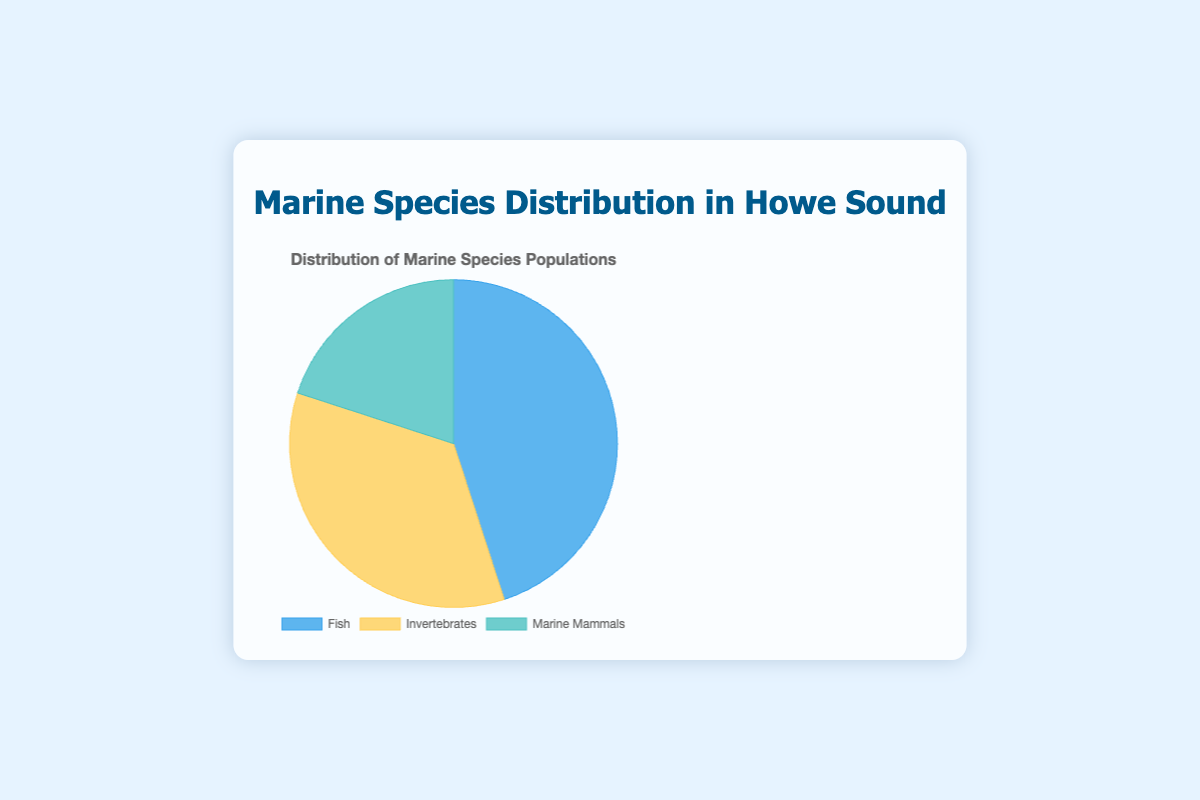How many types of marine species are represented in the diagram? There are labels for Fish, Invertebrates, and Marine Mammals. Counting these categories gives us 3 types.
Answer: 3 Which type of marine species has the highest population percentage in Howe Sound? The Fish category has the largest slice in the pie chart, labeled with 45%.
Answer: Fish What is the combined percentage of Fish and Invertebrates in the chart? Summing the percentages for Fish (45%) and Invertebrates (35%), we get 45 + 35 = 80%.
Answer: 80% By how much does the percentage of Fish exceed that of Marine Mammals? The percentage for Fish is 45%, and for Marine Mammals, it is 20%. The difference is 45 - 20 = 25%.
Answer: 25% What is the average percentage of the three species categories? Adding the percentages for Fish (45%), Invertebrates (35%), and Marine Mammals (20%) gives 45 + 35 + 20 = 100. Dividing this by 3 gives an average of 100 / 3 ≈ 33.33%.
Answer: 33.33% Which category has the smallest representation, and what is its percentage? The slice labeled Marine Mammals represents 20%, which is the smallest percentage shown in the pie chart.
Answer: Marine Mammals, 20% What is the percentage difference between Invertebrates and Marine Mammals? Subtract the percentage of Marine Mammals (20%) from that of Invertebrates (35%). The difference is 35 - 20 = 15%.
Answer: 15% If another species were to be found representing 10% of the total population, what would be the new percentage for the Invertebrates? If a new species represents 10%, the total now becomes 100 + 10 = 110%. The Invertebrates originally had 35%, so their new percentage would be (35/110) * 100 ≈ 31.82%.
Answer: 31.82% 